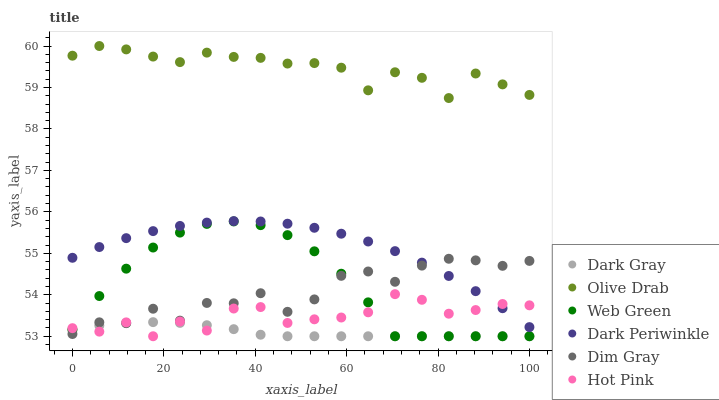Does Dark Gray have the minimum area under the curve?
Answer yes or no. Yes. Does Olive Drab have the maximum area under the curve?
Answer yes or no. Yes. Does Hot Pink have the minimum area under the curve?
Answer yes or no. No. Does Hot Pink have the maximum area under the curve?
Answer yes or no. No. Is Dark Gray the smoothest?
Answer yes or no. Yes. Is Dim Gray the roughest?
Answer yes or no. Yes. Is Hot Pink the smoothest?
Answer yes or no. No. Is Hot Pink the roughest?
Answer yes or no. No. Does Hot Pink have the lowest value?
Answer yes or no. Yes. Does Dark Periwinkle have the lowest value?
Answer yes or no. No. Does Olive Drab have the highest value?
Answer yes or no. Yes. Does Hot Pink have the highest value?
Answer yes or no. No. Is Hot Pink less than Olive Drab?
Answer yes or no. Yes. Is Olive Drab greater than Hot Pink?
Answer yes or no. Yes. Does Dark Periwinkle intersect Hot Pink?
Answer yes or no. Yes. Is Dark Periwinkle less than Hot Pink?
Answer yes or no. No. Is Dark Periwinkle greater than Hot Pink?
Answer yes or no. No. Does Hot Pink intersect Olive Drab?
Answer yes or no. No. 